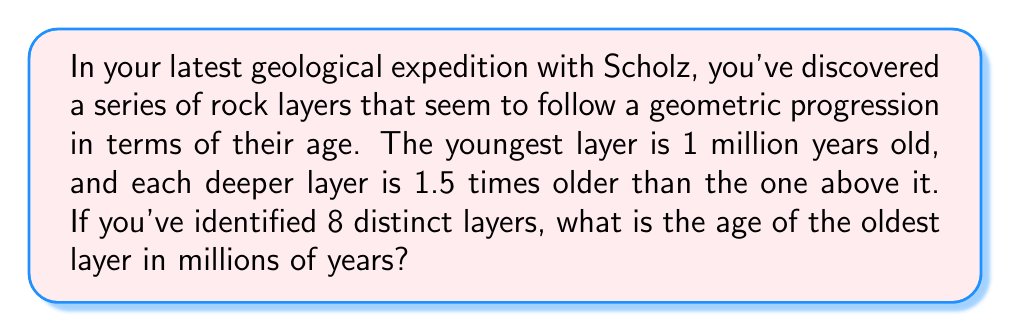Could you help me with this problem? Let's approach this step-by-step:

1) We're dealing with a geometric progression where:
   - The first term (youngest layer) $a_1 = 1$ million years
   - The common ratio $r = 1.5$
   - We want to find the 8th term

2) In a geometric progression, the nth term is given by the formula:
   $a_n = a_1 \cdot r^{n-1}$

3) In this case, we're looking for the 8th term, so n = 8:
   $a_8 = 1 \cdot 1.5^{8-1}$

4) Let's calculate this:
   $a_8 = 1 \cdot 1.5^7$

5) Now, let's compute $1.5^7$:
   $$1.5^7 = 1.5 \cdot 1.5 \cdot 1.5 \cdot 1.5 \cdot 1.5 \cdot 1.5 \cdot 1.5 = 17.0859375$$

6) Therefore, the age of the oldest layer is:
   $a_8 = 1 \cdot 17.0859375 = 17.0859375$ million years

7) Rounding to two decimal places for practical purposes:
   $a_8 \approx 17.09$ million years
Answer: 17.09 million years 